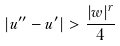<formula> <loc_0><loc_0><loc_500><loc_500>| u ^ { \prime \prime } - u ^ { \prime } | > \frac { | w | ^ { r } } { 4 }</formula> 